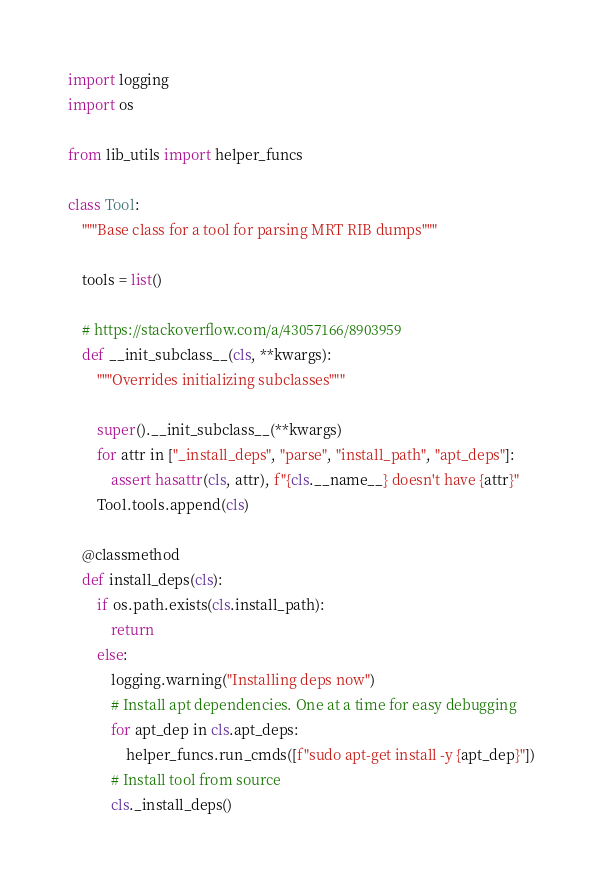Convert code to text. <code><loc_0><loc_0><loc_500><loc_500><_Python_>import logging
import os

from lib_utils import helper_funcs

class Tool:
    """Base class for a tool for parsing MRT RIB dumps"""

    tools = list()

    # https://stackoverflow.com/a/43057166/8903959
    def __init_subclass__(cls, **kwargs):
        """Overrides initializing subclasses"""

        super().__init_subclass__(**kwargs)
        for attr in ["_install_deps", "parse", "install_path", "apt_deps"]:
            assert hasattr(cls, attr), f"{cls.__name__} doesn't have {attr}"
        Tool.tools.append(cls)

    @classmethod
    def install_deps(cls):
        if os.path.exists(cls.install_path):
            return
        else:
            logging.warning("Installing deps now")
            # Install apt dependencies. One at a time for easy debugging
            for apt_dep in cls.apt_deps:
                helper_funcs.run_cmds([f"sudo apt-get install -y {apt_dep}"])
            # Install tool from source
            cls._install_deps()
</code> 